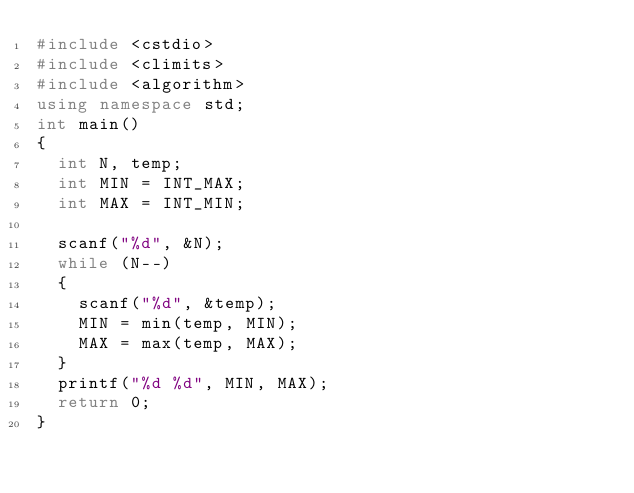<code> <loc_0><loc_0><loc_500><loc_500><_C++_>#include <cstdio>
#include <climits>
#include <algorithm>
using namespace std;
int main()
{
	int N, temp;
	int MIN = INT_MAX;
	int MAX = INT_MIN;

	scanf("%d", &N);
	while (N--)
	{
		scanf("%d", &temp);
		MIN = min(temp, MIN);
		MAX = max(temp, MAX);
	}
	printf("%d %d", MIN, MAX);
	return 0;
}
</code> 